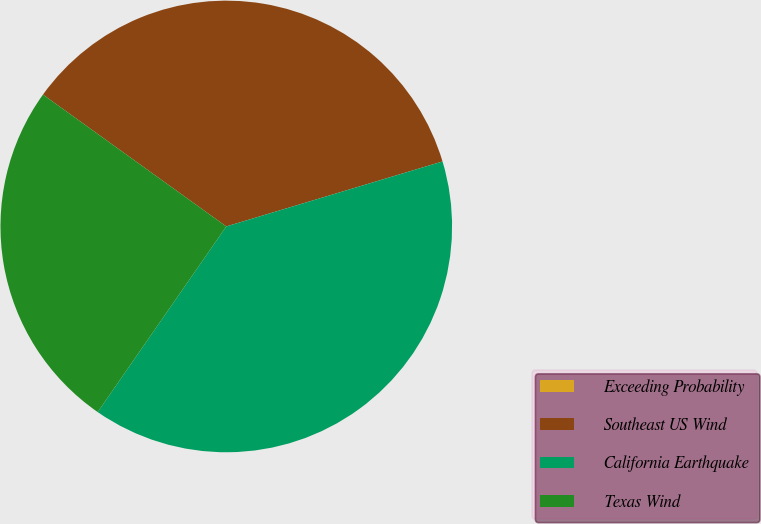<chart> <loc_0><loc_0><loc_500><loc_500><pie_chart><fcel>Exceeding Probability<fcel>Southeast US Wind<fcel>California Earthquake<fcel>Texas Wind<nl><fcel>0.0%<fcel>35.43%<fcel>39.29%<fcel>25.28%<nl></chart> 